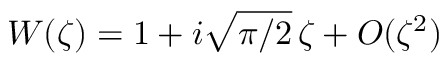Convert formula to latex. <formula><loc_0><loc_0><loc_500><loc_500>W ( \zeta ) = 1 + i \sqrt { \pi / 2 } \, \zeta + O ( \zeta ^ { 2 } )</formula> 